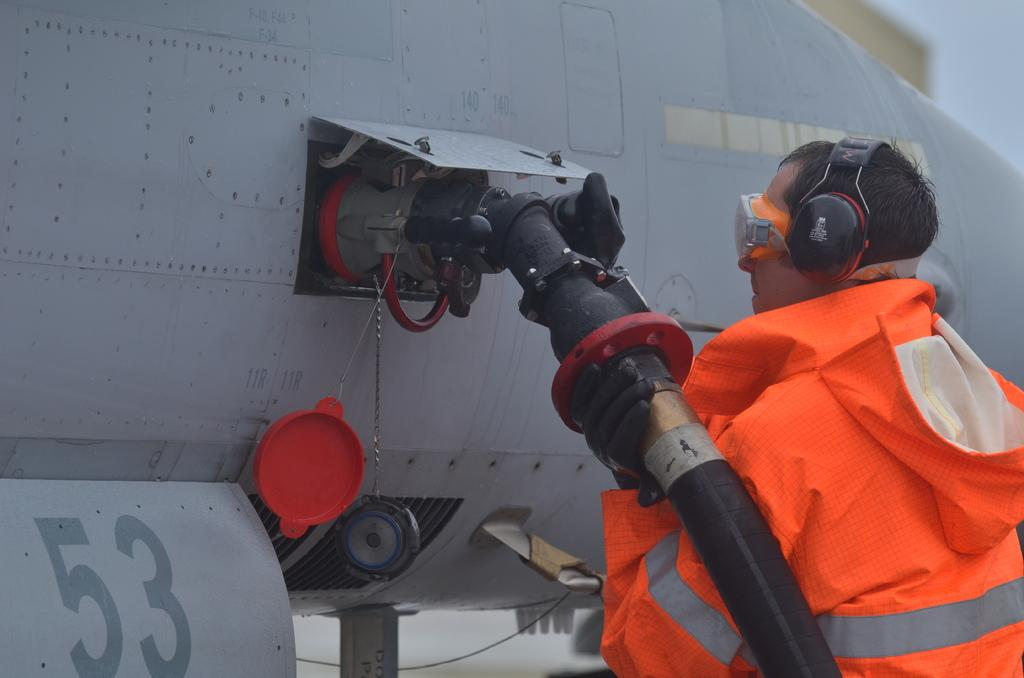What is the man doing on the right side of the image? The man is standing on the right side of the image. What is the man holding in the image? The man is holding a pipe in the image. What is the man feeling in the image? The man is feeling something in the image. What can be seen in the center of the image? There is an airplane in the center of the image. What type of boot is the man's son wearing in the image? There is no mention of a son or a boot in the image; the man is the only person present. 